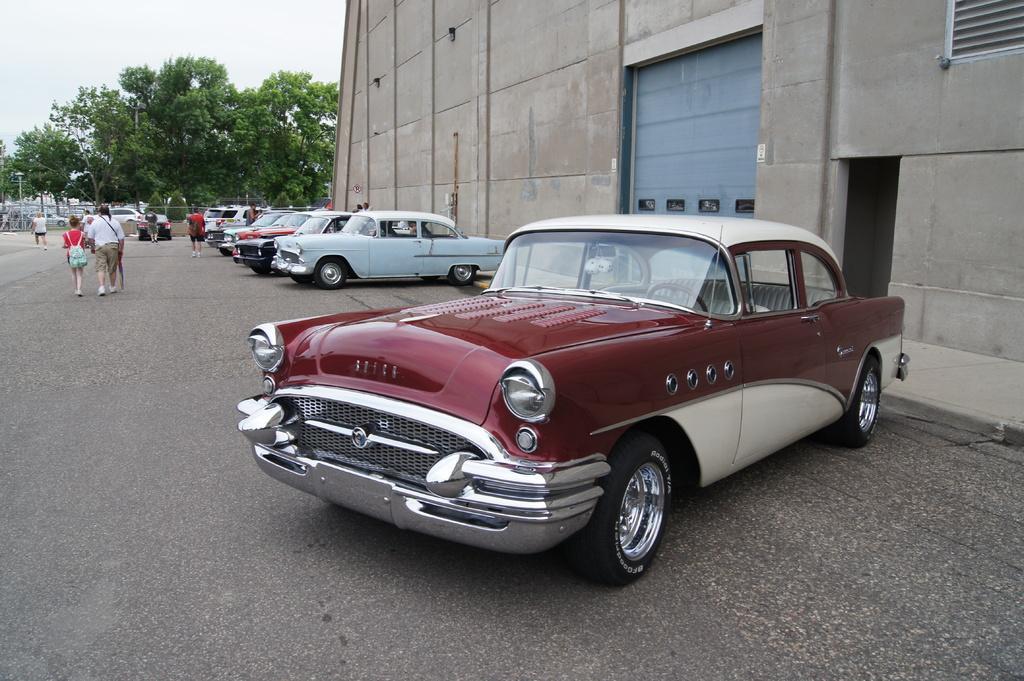Describe this image in one or two sentences. In the image there are many vehicles and people on the road, on the right side there is a building, in the background there are trees. 